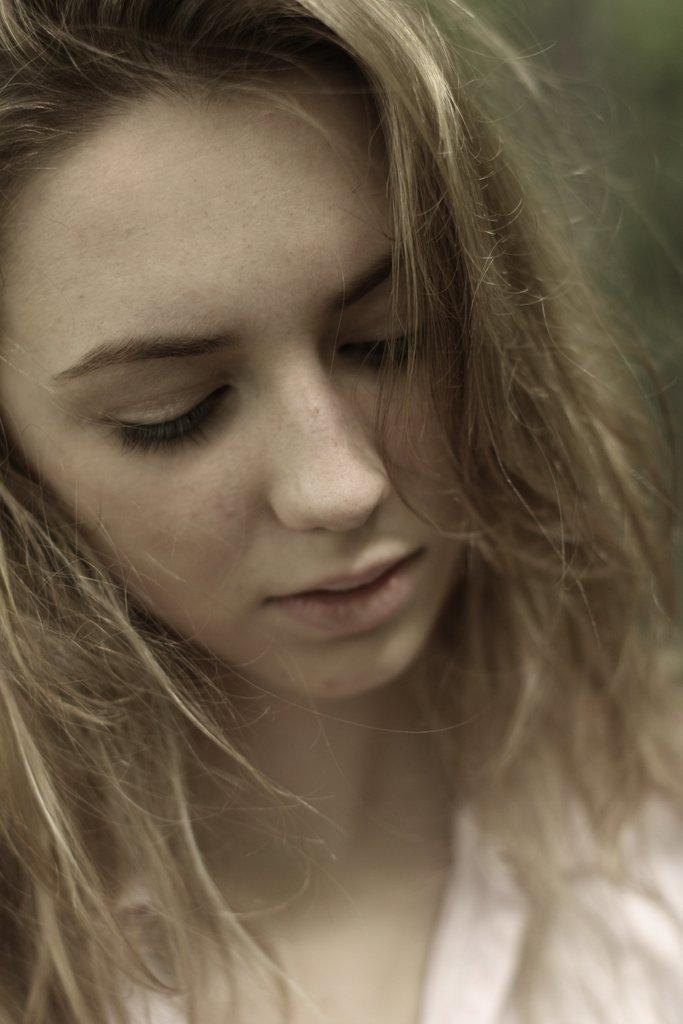Who is present in the image? There is a girl in the image. What type of polish does the girl use on her nails in the image? There is no information about the girl's nails or any polish in the image. 